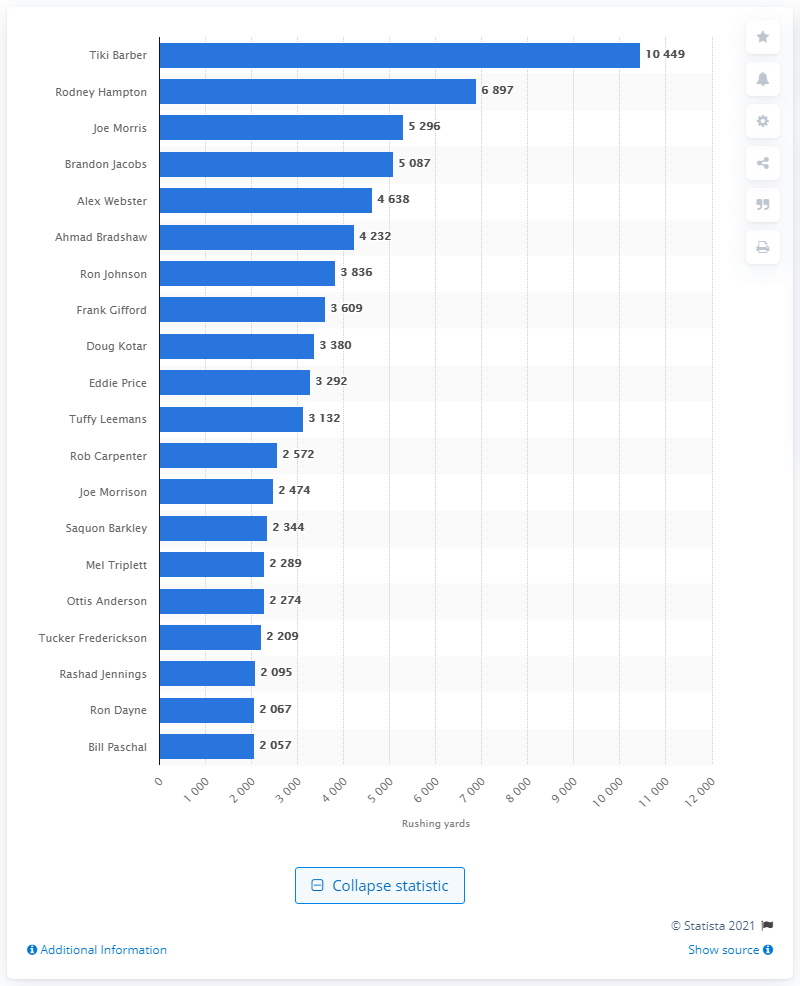List a handful of essential elements in this visual. Tiki Barber is the career rushing leader of the New York Giants. 